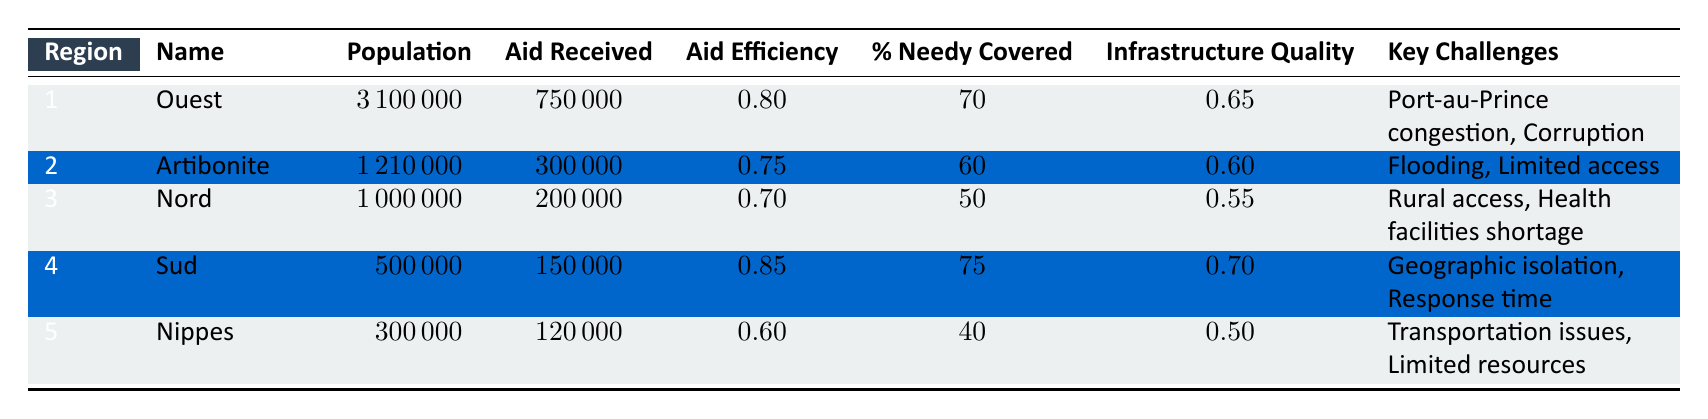What is the aid efficiency of the Ouest region? The aid efficiency for the Ouest region is directly available in the table under the "Aid Efficiency" column. According to the data, it is 0.80.
Answer: 0.80 Which region has the highest percentage of needy covered? We can compare the "% Needy Covered" values for each region. Sud has 75%, which is higher than the other regions listed.
Answer: Sud How many people are covered by aid in the Nord region? To find the number of needy covered in the Nord region, we take its population (1,000,000) and apply the percentage of needy covered (50%). This gives us 1,000,000 * 0.50 = 500,000 people covered.
Answer: 500000 What are the key challenges faced in the Artibonite region? The table lists the key challenges for the Artibonite region, which are "Flooding" and "Limited access."
Answer: Flooding, Limited access Is the infrastructure quality in the Nippes region better than that in the Ouest region? We compare the infrastructure quality values: Nippes has a value of 0.50, while Ouest has a value of 0.65. Since 0.50 is less than 0.65, the infrastructure quality in Nippes is not better than in Ouest.
Answer: No What is the total population of the regions with an aid efficiency greater than 0.75? We identify the regions with aid efficiency greater than 0.75: Ouest (3,100,000) and Sud (500,000). The total population is 3,100,000 + 500,000 = 3,600,000.
Answer: 3600000 Which region faced challenges related to transportation issues? The table indicates that the Nippes region faces challenges related to "Transportation issues."
Answer: Nippes Does the Artibonite region cover more of the needy population compared to the Nord region? The Artibonite has 60% of its needy population covered while the Nord region only has 50% covered, indicating Artibonite does cover more.
Answer: Yes 